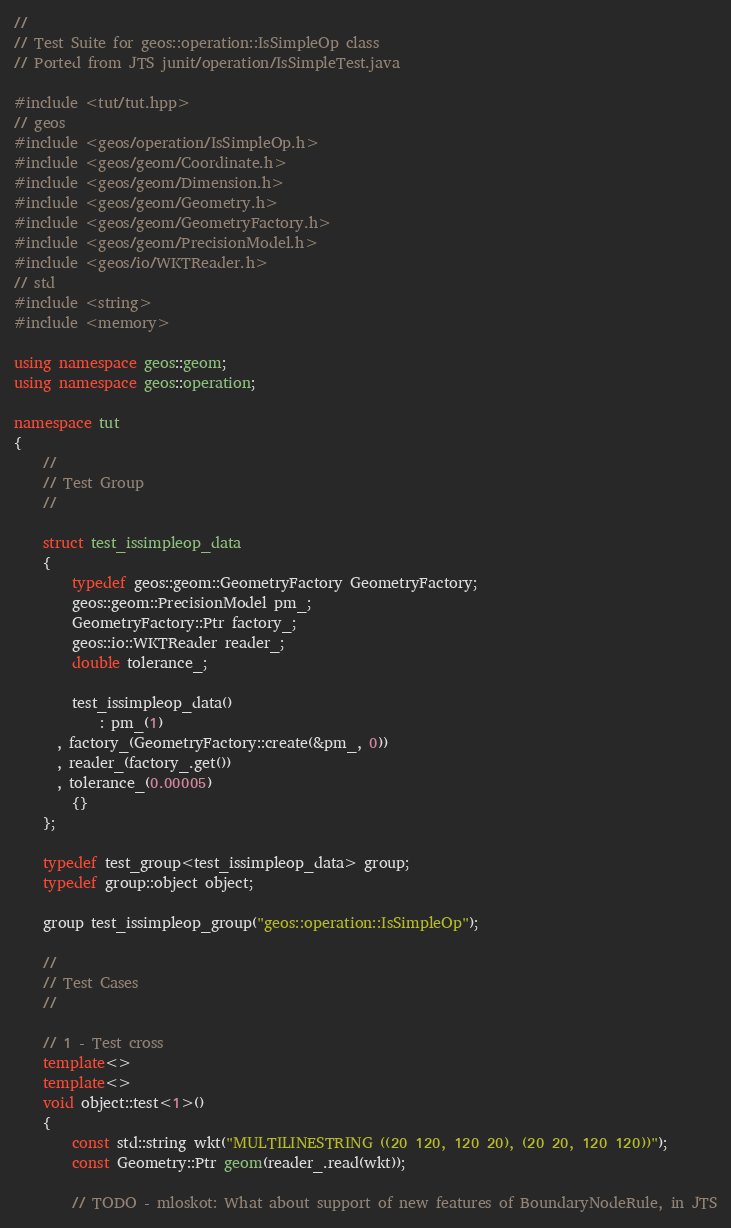<code> <loc_0><loc_0><loc_500><loc_500><_C++_>//
// Test Suite for geos::operation::IsSimpleOp class
// Ported from JTS junit/operation/IsSimpleTest.java

#include <tut/tut.hpp>
// geos
#include <geos/operation/IsSimpleOp.h>
#include <geos/geom/Coordinate.h>
#include <geos/geom/Dimension.h>
#include <geos/geom/Geometry.h>
#include <geos/geom/GeometryFactory.h>
#include <geos/geom/PrecisionModel.h>
#include <geos/io/WKTReader.h>
// std
#include <string>
#include <memory>

using namespace geos::geom;
using namespace geos::operation;

namespace tut
{
    //
    // Test Group
    //

    struct test_issimpleop_data
    {
        typedef geos::geom::GeometryFactory GeometryFactory;
        geos::geom::PrecisionModel pm_;
        GeometryFactory::Ptr factory_;
        geos::io::WKTReader reader_;
        double tolerance_;

        test_issimpleop_data()
			: pm_(1)
      , factory_(GeometryFactory::create(&pm_, 0))
      , reader_(factory_.get())
      , tolerance_(0.00005)
        {}
    };

    typedef test_group<test_issimpleop_data> group;
    typedef group::object object;

    group test_issimpleop_group("geos::operation::IsSimpleOp");

    //
    // Test Cases
    //

    // 1 - Test cross
    template<>
    template<>
    void object::test<1>()
    {
        const std::string wkt("MULTILINESTRING ((20 120, 120 20), (20 20, 120 120))");
        const Geometry::Ptr geom(reader_.read(wkt));

        // TODO - mloskot: What about support of new features of BoundaryNodeRule, in JTS
</code> 